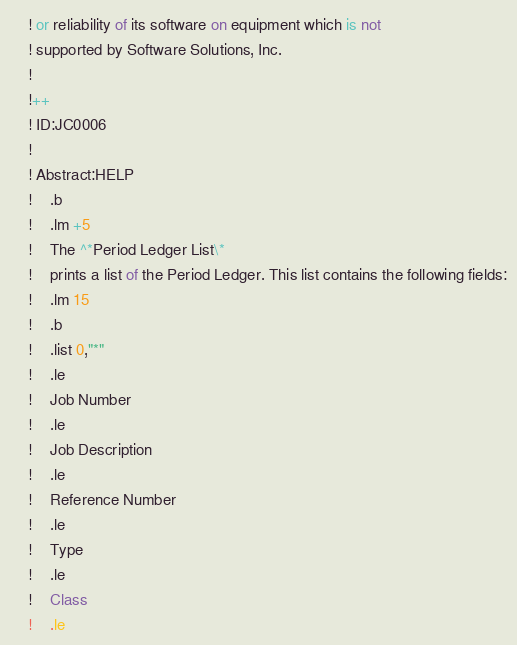<code> <loc_0><loc_0><loc_500><loc_500><_VisualBasic_>	! or reliability of its software on equipment which is not
	! supported by Software Solutions, Inc.
	!
	!++
	! ID:JC0006
	!
	! Abstract:HELP
	!	.b
	!	.lm +5
	!	The ^*Period Ledger List\*
	!	prints a list of the Period Ledger. This list contains the following fields:
	!	.lm 15
	!	.b
	!	.list 0,"*"
	!	.le
	!	Job Number
	!	.le
	!	Job Description
	!	.le
	!	Reference Number
	!	.le
	!	Type
	!	.le
	!	Class
	!	.le</code> 